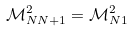Convert formula to latex. <formula><loc_0><loc_0><loc_500><loc_500>\mathcal { M } _ { N N + 1 } ^ { 2 } = \mathcal { M } _ { N 1 } ^ { 2 }</formula> 